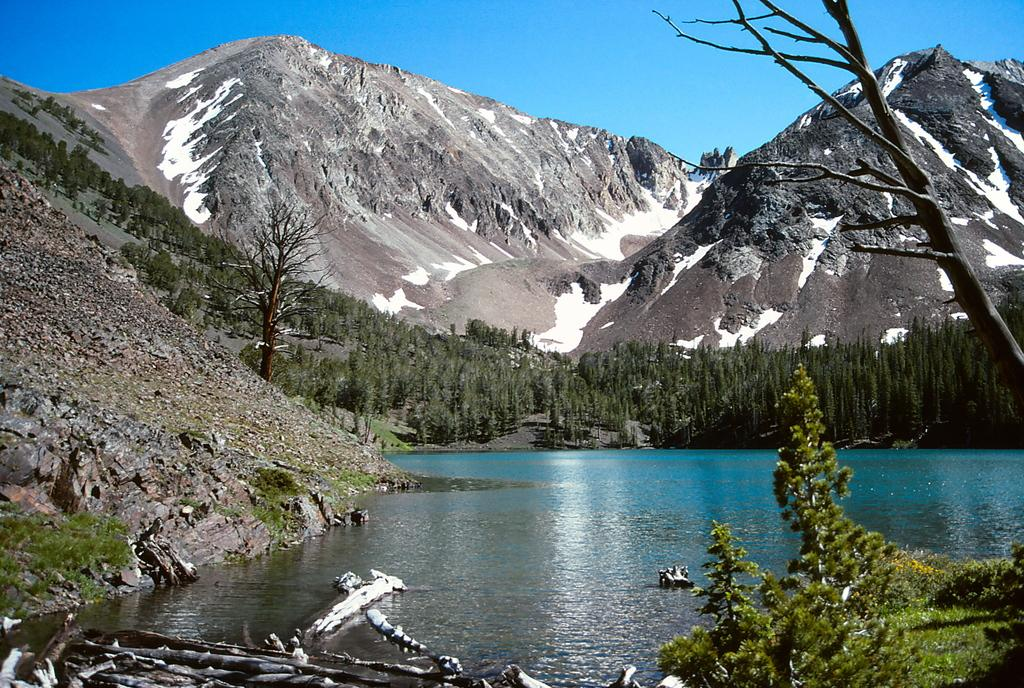What type of natural landscape is depicted in the image? The image features mountains. What is the weather like in the image? There is snow in the image, indicating a cold climate. What type of vegetation can be seen in the image? There are trees, plants, and grass visible in the image. What is the body of water in the image? There is water in the image. What can be seen in the background of the image? The sky is visible in the background of the image. What type of loaf is being photographed by the camera on the street in the image? There is no loaf or camera present in the image; it features a natural landscape with mountains, snow, trees, plants, grass, water, and a visible sky. 